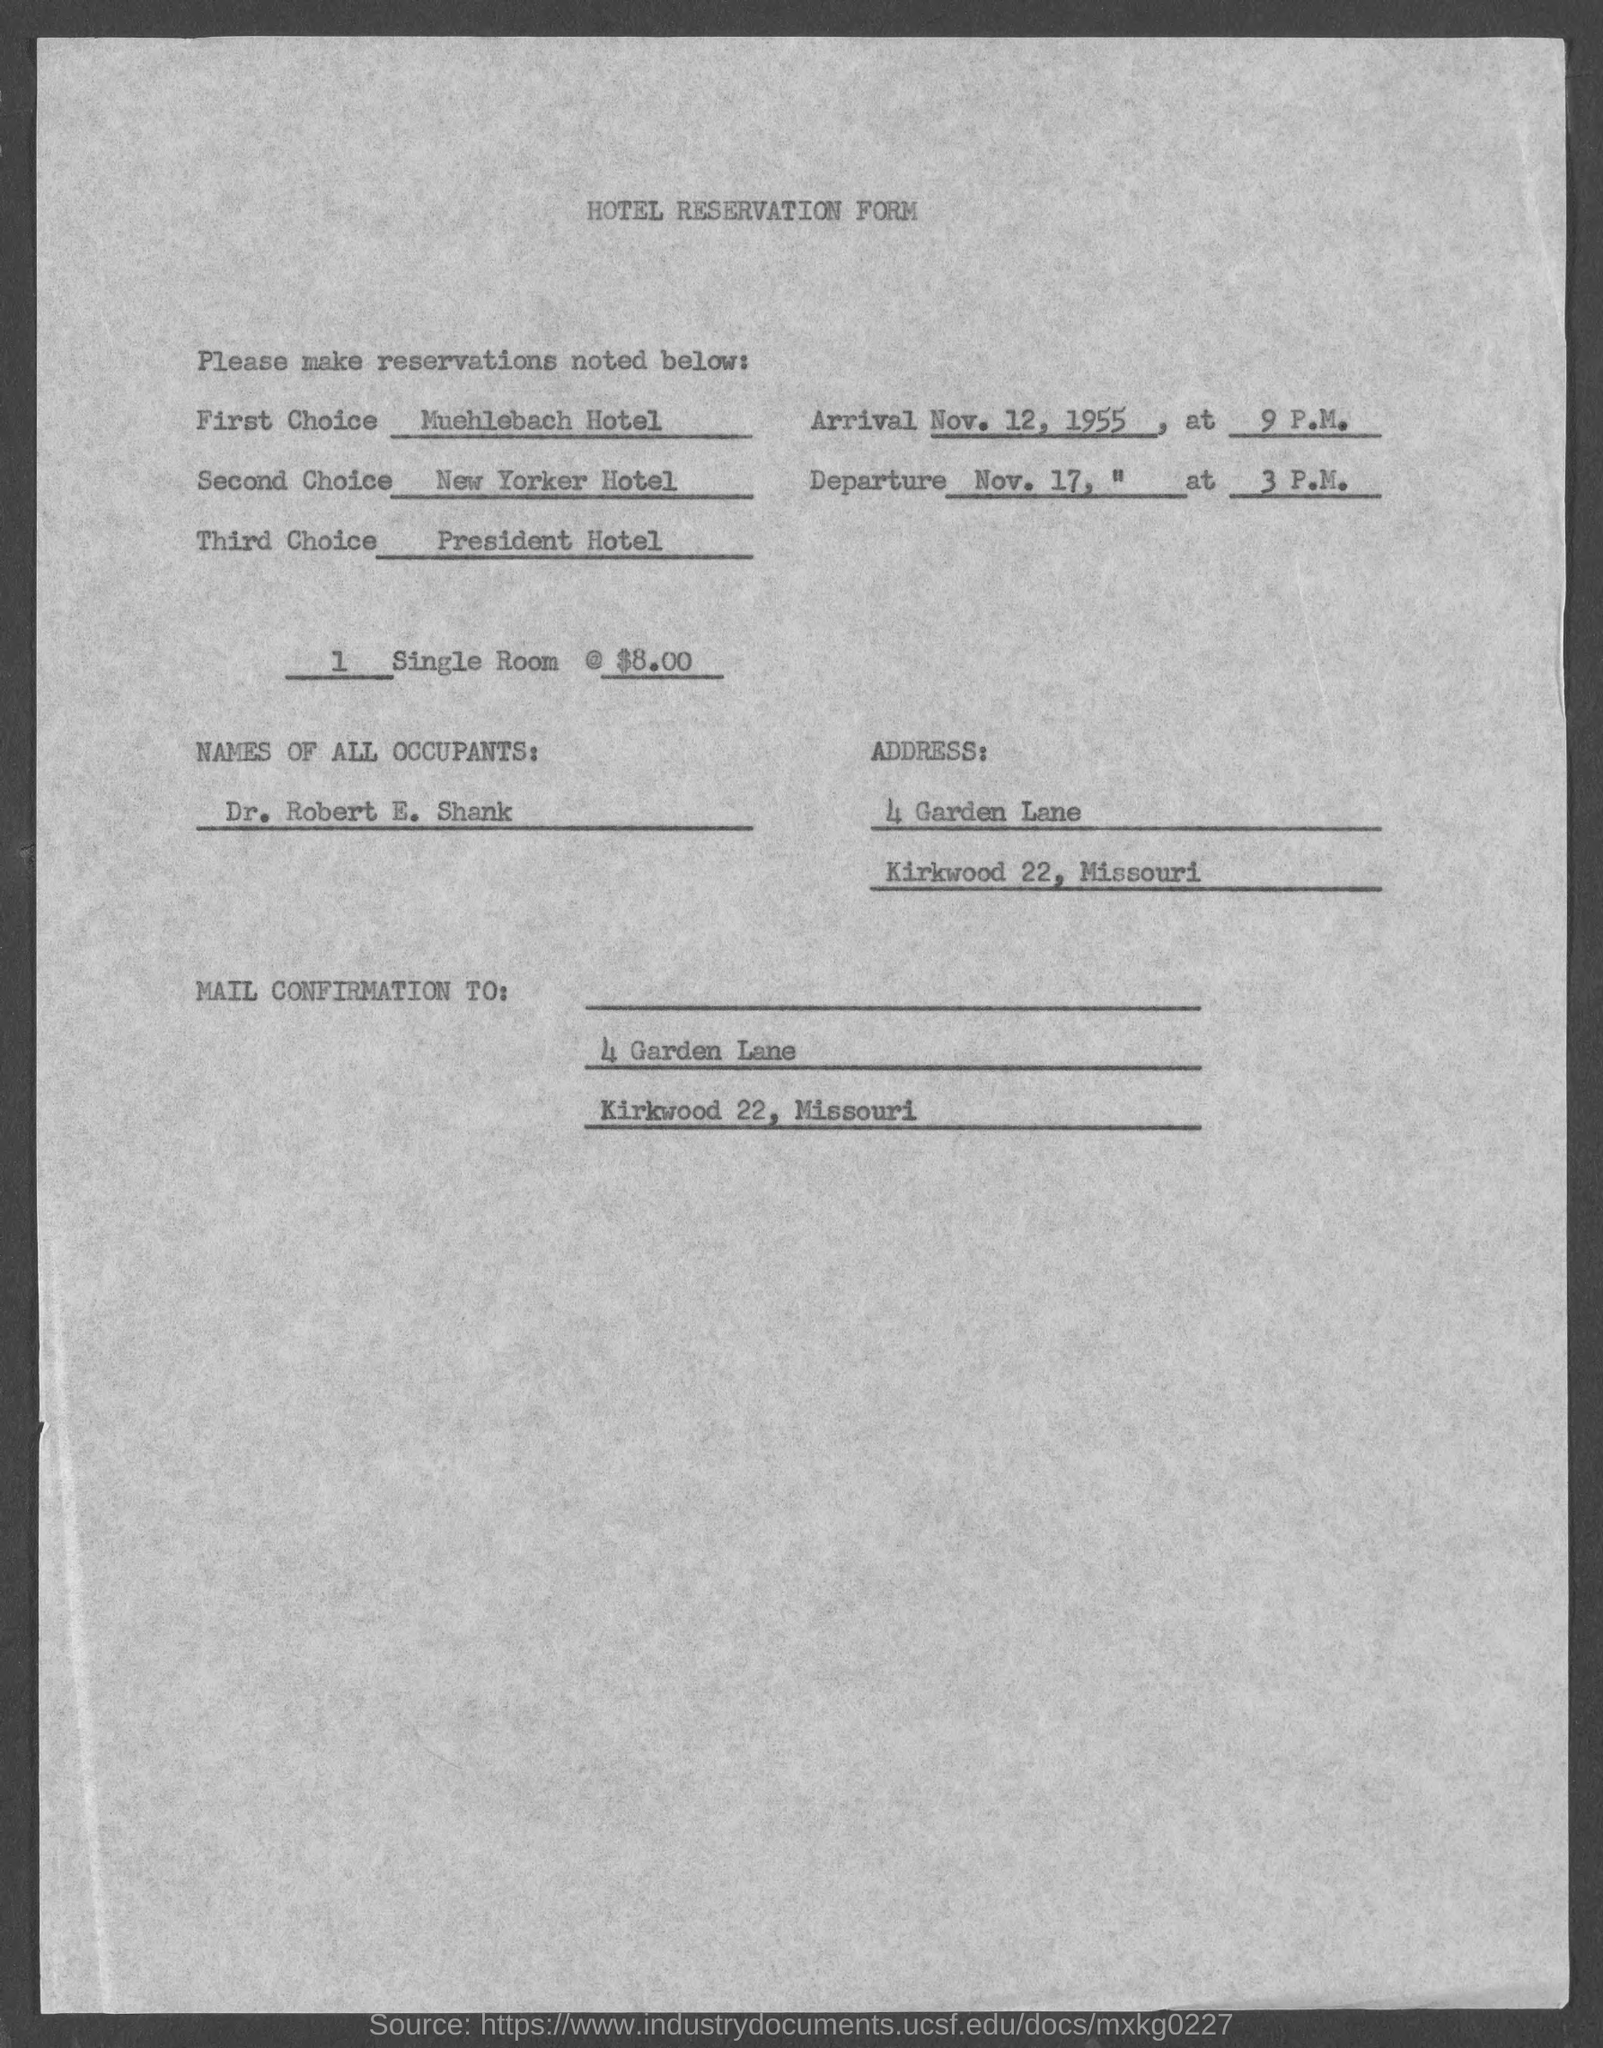What is the name of the form?
Your answer should be very brief. Hotel reservation form. What is the name of all occupants?
Your answer should be compact. Dr. Robert E. Shank. 